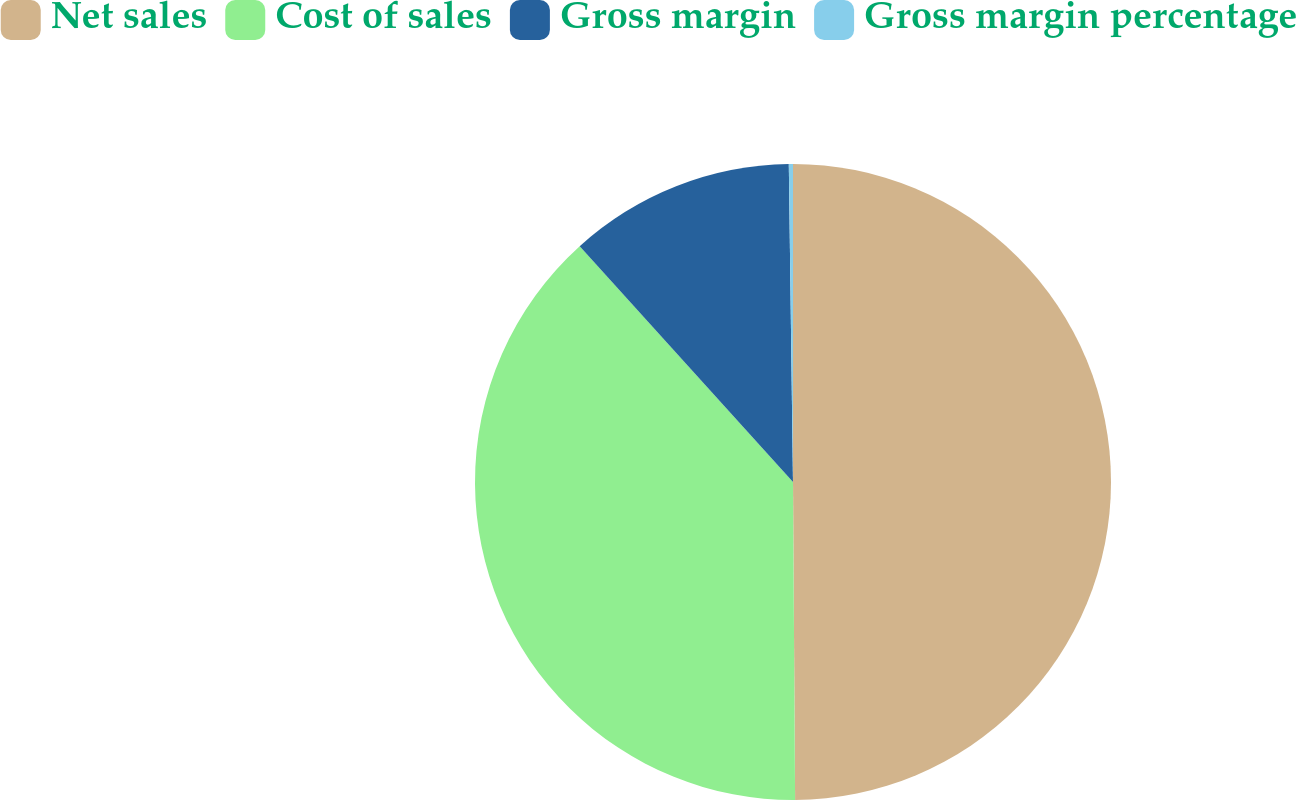<chart> <loc_0><loc_0><loc_500><loc_500><pie_chart><fcel>Net sales<fcel>Cost of sales<fcel>Gross margin<fcel>Gross margin percentage<nl><fcel>49.89%<fcel>38.4%<fcel>11.49%<fcel>0.21%<nl></chart> 